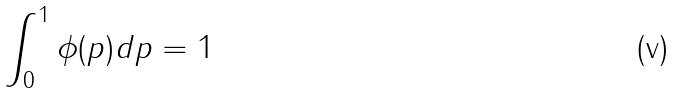<formula> <loc_0><loc_0><loc_500><loc_500>\int _ { 0 } ^ { 1 } \phi ( p ) d p = 1</formula> 